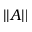<formula> <loc_0><loc_0><loc_500><loc_500>\left | \left | A \right | \right |</formula> 